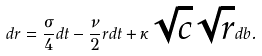<formula> <loc_0><loc_0><loc_500><loc_500>d r = \frac { \sigma } { 4 } d t - \frac { \nu } { 2 } r d t + \kappa \sqrt { c } \sqrt { r } d b .</formula> 